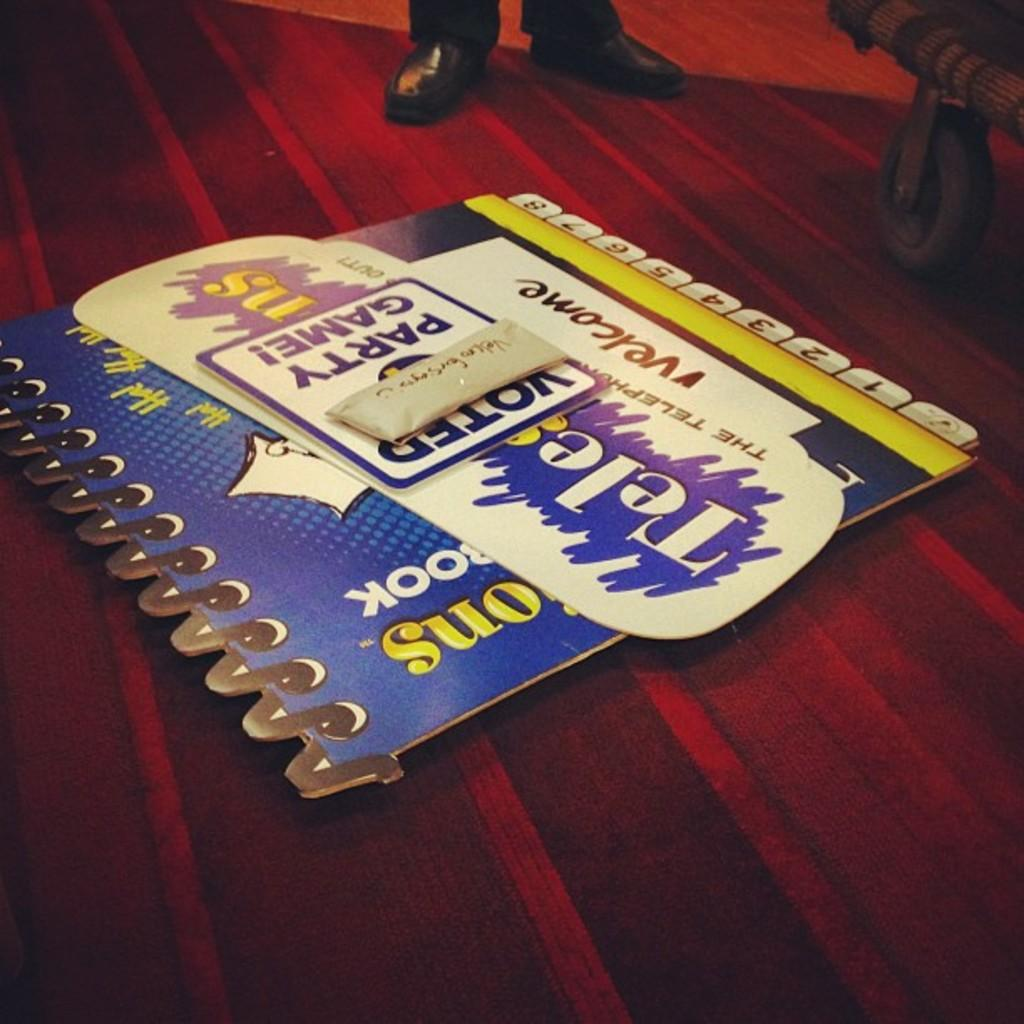What is placed on the red carpet in the image? There is a cardboard on the red carpet. What can be seen on the cardboard? There is writing on the cardboard. What objects are visible in the background of the image? There are two shoes and a wheel in the background. How many pigs are present in the image? There are no pigs present in the image. What type of waste can be seen in the image? There is no waste visible in the image. 